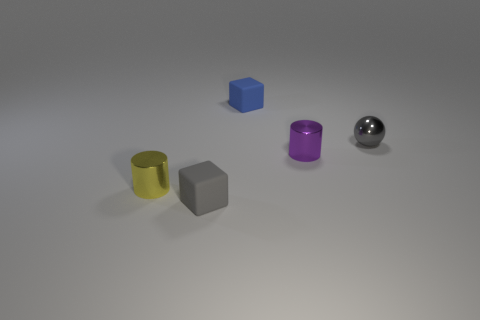The shiny cylinder on the left side of the tiny purple object is what color?
Your answer should be compact. Yellow. The gray thing that is made of the same material as the tiny blue object is what shape?
Your answer should be compact. Cube. Is there any other thing of the same color as the tiny shiny ball?
Your response must be concise. Yes. Is the number of metallic objects that are to the right of the gray sphere greater than the number of balls to the right of the yellow metal thing?
Offer a very short reply. No. What number of yellow objects have the same size as the ball?
Your response must be concise. 1. Are there fewer small yellow metallic cylinders left of the small yellow thing than matte things that are on the right side of the gray cube?
Ensure brevity in your answer.  Yes. Are there any other purple things of the same shape as the purple metal object?
Ensure brevity in your answer.  No. Is the blue rubber thing the same shape as the yellow metallic object?
Your response must be concise. No. What number of big objects are either purple metal cylinders or blue objects?
Make the answer very short. 0. Is the number of gray matte objects greater than the number of big red shiny cylinders?
Give a very brief answer. Yes. 